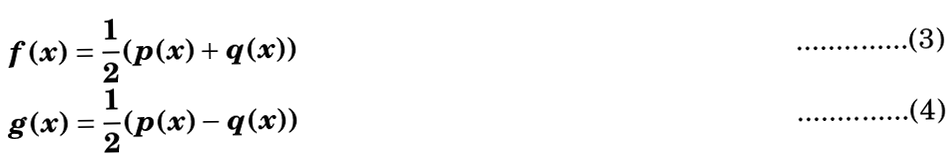<formula> <loc_0><loc_0><loc_500><loc_500>f ( x ) & = \frac { 1 } { 2 } ( p ( x ) + q ( x ) ) \\ g ( x ) & = \frac { 1 } { 2 } ( p ( x ) - q ( x ) )</formula> 